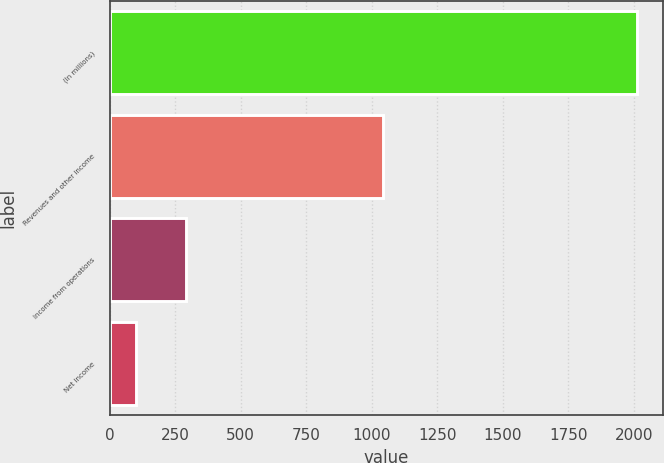<chart> <loc_0><loc_0><loc_500><loc_500><bar_chart><fcel>(In millions)<fcel>Revenues and other income<fcel>Income from operations<fcel>Net income<nl><fcel>2011<fcel>1043<fcel>292<fcel>101<nl></chart> 